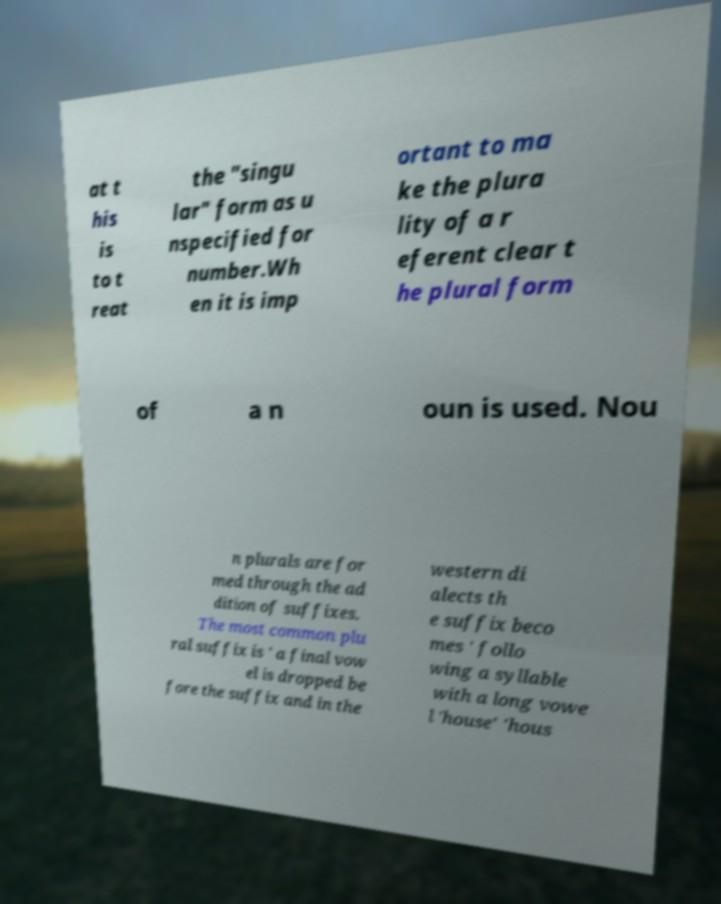Could you assist in decoding the text presented in this image and type it out clearly? at t his is to t reat the "singu lar" form as u nspecified for number.Wh en it is imp ortant to ma ke the plura lity of a r eferent clear t he plural form of a n oun is used. Nou n plurals are for med through the ad dition of suffixes. The most common plu ral suffix is ' a final vow el is dropped be fore the suffix and in the western di alects th e suffix beco mes ' follo wing a syllable with a long vowe l 'house' 'hous 